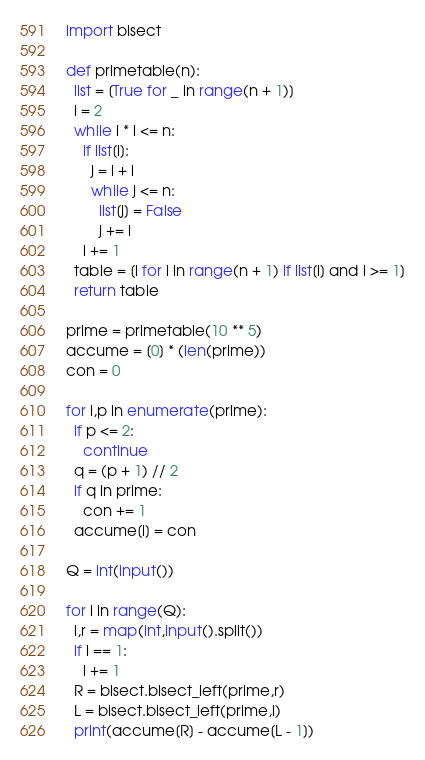<code> <loc_0><loc_0><loc_500><loc_500><_Python_>import bisect

def primetable(n):
  list = [True for _ in range(n + 1)]
  i = 2
  while i * i <= n:
    if list[i]:
      j = i + i
      while j <= n:
        list[j] = False
        j += i
    i += 1
  table = [i for i in range(n + 1) if list[i] and i >= 1]
  return table

prime = primetable(10 ** 5)
accume = [0] * (len(prime))
con = 0

for i,p in enumerate(prime):
  if p <= 2:
    continue
  q = (p + 1) // 2
  if q in prime:
    con += 1
  accume[i] = con

Q = int(input())

for i in range(Q):
  l,r = map(int,input().split())
  if l == 1:
    l += 1
  R = bisect.bisect_left(prime,r)
  L = bisect.bisect_left(prime,l)
  print(accume[R] - accume[L - 1])
</code> 